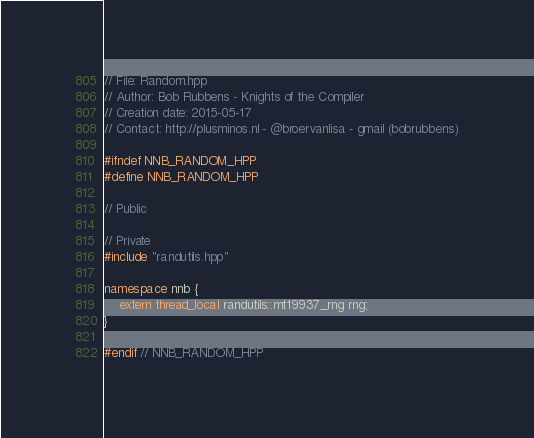<code> <loc_0><loc_0><loc_500><loc_500><_C++_>// File: Random.hpp
// Author: Bob Rubbens - Knights of the Compiler
// Creation date: 2015-05-17
// Contact: http://plusminos.nl - @broervanlisa - gmail (bobrubbens)

#ifndef NNB_RANDOM_HPP
#define NNB_RANDOM_HPP

// Public

// Private
#include "randutils.hpp"

namespace nnb {
	extern thread_local randutils::mt19937_rng rng;
}

#endif // NNB_RANDOM_HPP
</code> 